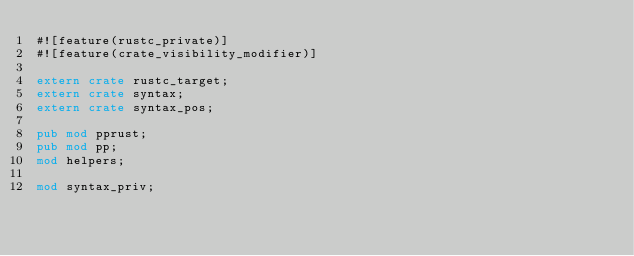Convert code to text. <code><loc_0><loc_0><loc_500><loc_500><_Rust_>#![feature(rustc_private)]
#![feature(crate_visibility_modifier)]

extern crate rustc_target;
extern crate syntax;
extern crate syntax_pos;

pub mod pprust;
pub mod pp;
mod helpers;

mod syntax_priv;
</code> 